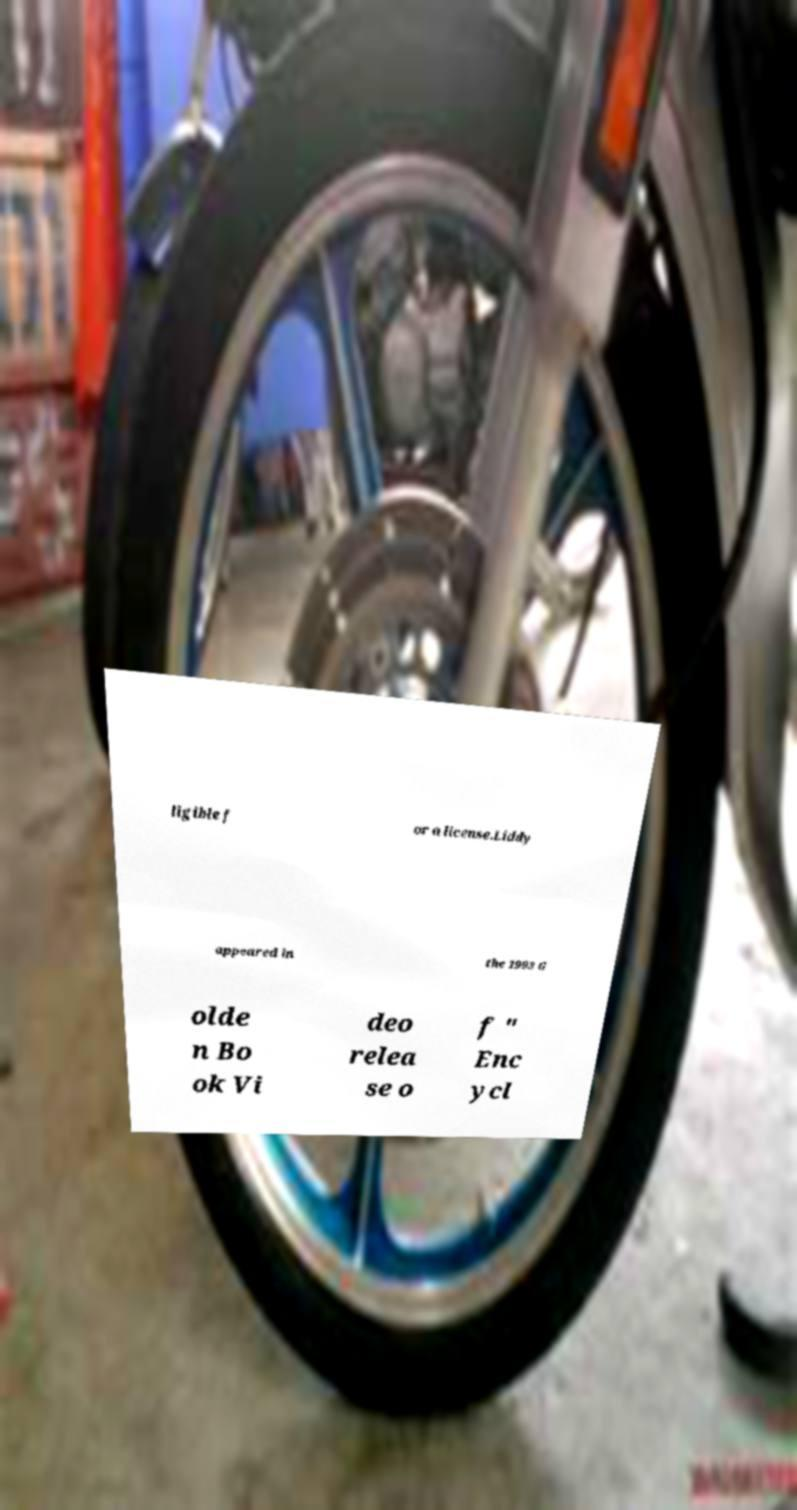Please read and relay the text visible in this image. What does it say? ligible f or a license.Liddy appeared in the 1993 G olde n Bo ok Vi deo relea se o f " Enc ycl 